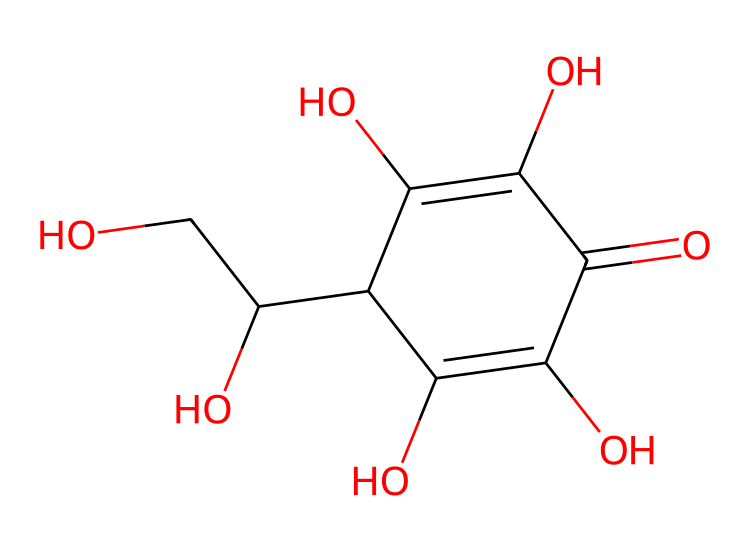How many carbon atoms are in the chemical structure? By examining the SMILES representation, we can identify the number of 'C' characters present. Counting these, we find there are six carbon atoms in the structure.
Answer: six What is the main functional group present in vitamin C? Looking at the chemical structure, we recognize the presence of multiple hydroxyl (–OH) groups. These functional groups are prominently featured in vitamin C, indicating its classification as a vitamin with hydroxyl functional groups.
Answer: hydroxyl What is the total number of oxygen atoms? In the SMILES representation, we can count the number of 'O' characters to determine the total number of oxygen atoms present in the structure. There are four oxygen atoms in total.
Answer: four What type of molecular geometry does vitamin C primarily exhibit? Analyzing the structure, we see the presence of multiple hydroxyl groups in a cyclic arrangement, which suggests that vitamin C exhibits a tetrahedral geometry around the carbon atoms linked to these hydroxyl groups.
Answer: tetrahedral How does the presence of hydroxyl groups affect the solubility of vitamin C? The multiple hydroxyl groups in the molecule increase hydrogen bonding potential with water molecules, which significantly enhances the solubility of vitamin C in water compared to lipid-soluble vitamins.
Answer: increases solubility What implications does the molecular geometry of vitamin C have on its reactivity? The tetrahedral arrangement around the carbon atoms means that the structure can facilitate the formation of hydrogen bonds and alter the electronic environment, which can enhance its antioxidant properties and reactivity with free radicals.
Answer: enhances reactivity 